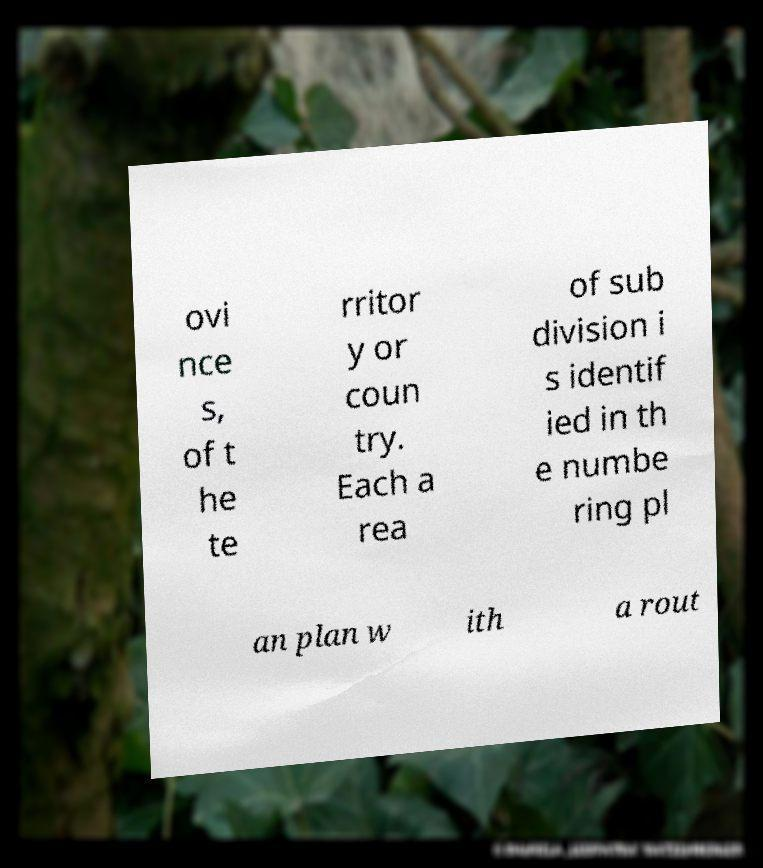There's text embedded in this image that I need extracted. Can you transcribe it verbatim? ovi nce s, of t he te rritor y or coun try. Each a rea of sub division i s identif ied in th e numbe ring pl an plan w ith a rout 